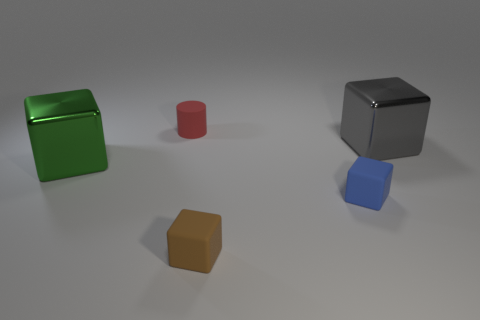What color is the metal thing that is behind the metal thing that is to the left of the small red cylinder?
Make the answer very short. Gray. What number of cubes are to the right of the red matte object and in front of the gray metallic cube?
Your answer should be compact. 2. What number of other metallic objects are the same shape as the green object?
Ensure brevity in your answer.  1. Do the gray cube and the red object have the same material?
Make the answer very short. No. The large metal object that is right of the big cube in front of the large gray shiny thing is what shape?
Ensure brevity in your answer.  Cube. There is a thing in front of the tiny blue rubber cube; how many brown cubes are on the left side of it?
Your answer should be compact. 0. What material is the small object that is to the left of the small blue matte thing and in front of the gray cube?
Offer a terse response. Rubber. The gray object that is the same size as the green metallic block is what shape?
Keep it short and to the point. Cube. There is a tiny rubber thing right of the small brown block in front of the large metal object to the right of the blue matte cube; what color is it?
Keep it short and to the point. Blue. What number of objects are either shiny things that are on the left side of the big gray cube or gray rubber things?
Keep it short and to the point. 1. 